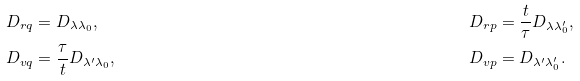<formula> <loc_0><loc_0><loc_500><loc_500>D _ { r q } & = D _ { \lambda \lambda _ { 0 } } , & D _ { r p } & = \frac { t } { \tau } D _ { \lambda \lambda _ { 0 } ^ { \prime } } , & \\ D _ { v q } & = \frac { \tau } { t } D _ { \lambda ^ { \prime } \lambda _ { 0 } } , & D _ { v p } & = D _ { \lambda ^ { \prime } \lambda _ { 0 } ^ { \prime } } . &</formula> 